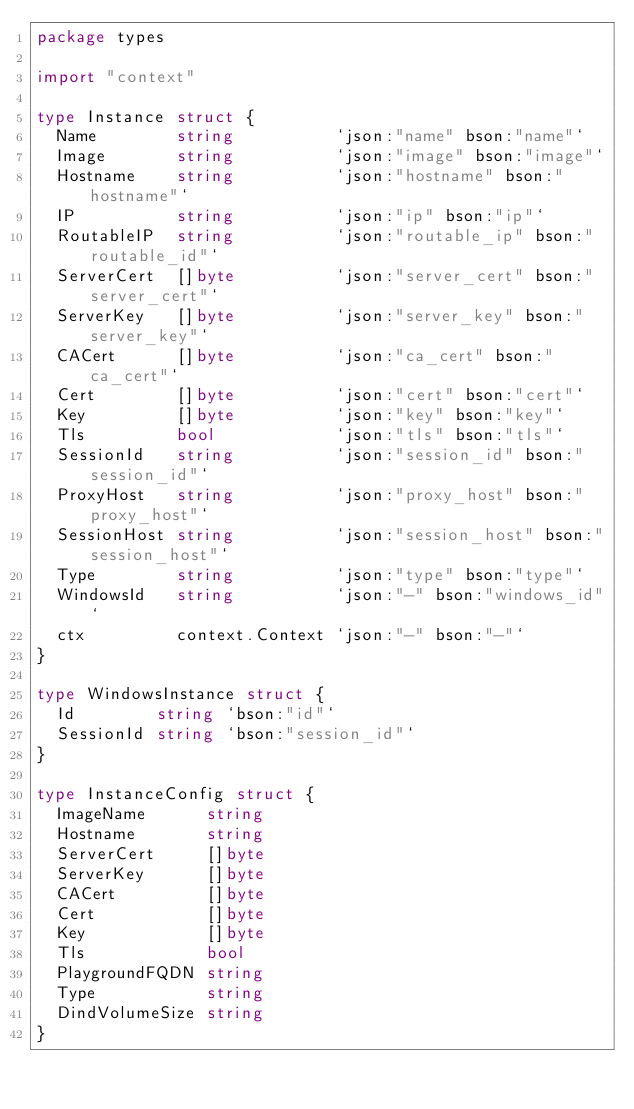Convert code to text. <code><loc_0><loc_0><loc_500><loc_500><_Go_>package types

import "context"

type Instance struct {
	Name        string          `json:"name" bson:"name"`
	Image       string          `json:"image" bson:"image"`
	Hostname    string          `json:"hostname" bson:"hostname"`
	IP          string          `json:"ip" bson:"ip"`
	RoutableIP  string          `json:"routable_ip" bson:"routable_id"`
	ServerCert  []byte          `json:"server_cert" bson:"server_cert"`
	ServerKey   []byte          `json:"server_key" bson:"server_key"`
	CACert      []byte          `json:"ca_cert" bson:"ca_cert"`
	Cert        []byte          `json:"cert" bson:"cert"`
	Key         []byte          `json:"key" bson:"key"`
	Tls         bool            `json:"tls" bson:"tls"`
	SessionId   string          `json:"session_id" bson:"session_id"`
	ProxyHost   string          `json:"proxy_host" bson:"proxy_host"`
	SessionHost string          `json:"session_host" bson:"session_host"`
	Type        string          `json:"type" bson:"type"`
	WindowsId   string          `json:"-" bson:"windows_id"`
	ctx         context.Context `json:"-" bson:"-"`
}

type WindowsInstance struct {
	Id        string `bson:"id"`
	SessionId string `bson:"session_id"`
}

type InstanceConfig struct {
	ImageName      string
	Hostname       string
	ServerCert     []byte
	ServerKey      []byte
	CACert         []byte
	Cert           []byte
	Key            []byte
	Tls            bool
	PlaygroundFQDN string
	Type           string
	DindVolumeSize string
}
</code> 